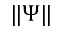<formula> <loc_0><loc_0><loc_500><loc_500>\| \Psi \|</formula> 